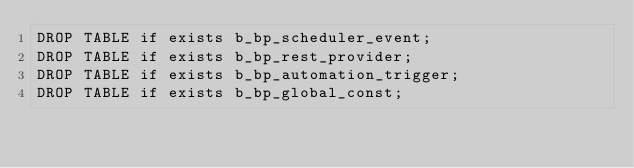<code> <loc_0><loc_0><loc_500><loc_500><_SQL_>DROP TABLE if exists b_bp_scheduler_event;
DROP TABLE if exists b_bp_rest_provider;
DROP TABLE if exists b_bp_automation_trigger;
DROP TABLE if exists b_bp_global_const;</code> 